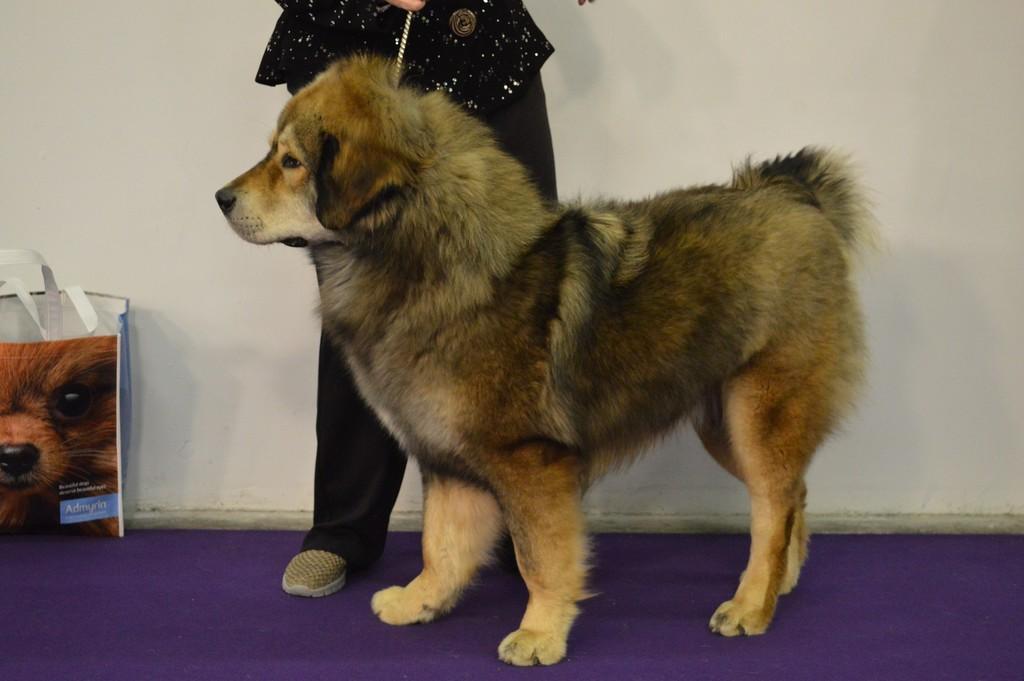How would you summarize this image in a sentence or two? In this picture there is a dog on the floor and we can see a bag and person, behind a person we can see wall. 